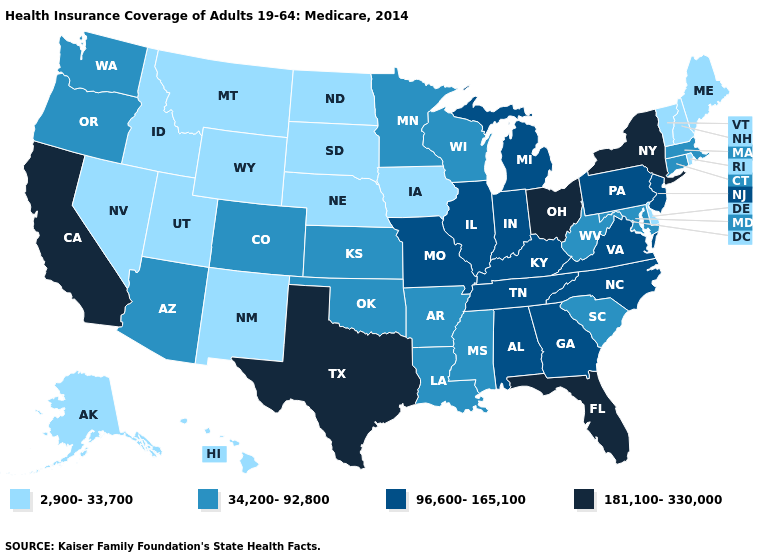Is the legend a continuous bar?
Quick response, please. No. Name the states that have a value in the range 2,900-33,700?
Be succinct. Alaska, Delaware, Hawaii, Idaho, Iowa, Maine, Montana, Nebraska, Nevada, New Hampshire, New Mexico, North Dakota, Rhode Island, South Dakota, Utah, Vermont, Wyoming. What is the value of Montana?
Write a very short answer. 2,900-33,700. What is the value of Wyoming?
Answer briefly. 2,900-33,700. What is the value of Delaware?
Write a very short answer. 2,900-33,700. Which states have the lowest value in the MidWest?
Answer briefly. Iowa, Nebraska, North Dakota, South Dakota. Which states have the lowest value in the USA?
Be succinct. Alaska, Delaware, Hawaii, Idaho, Iowa, Maine, Montana, Nebraska, Nevada, New Hampshire, New Mexico, North Dakota, Rhode Island, South Dakota, Utah, Vermont, Wyoming. Does Ohio have the highest value in the MidWest?
Concise answer only. Yes. Which states have the lowest value in the USA?
Be succinct. Alaska, Delaware, Hawaii, Idaho, Iowa, Maine, Montana, Nebraska, Nevada, New Hampshire, New Mexico, North Dakota, Rhode Island, South Dakota, Utah, Vermont, Wyoming. Name the states that have a value in the range 2,900-33,700?
Give a very brief answer. Alaska, Delaware, Hawaii, Idaho, Iowa, Maine, Montana, Nebraska, Nevada, New Hampshire, New Mexico, North Dakota, Rhode Island, South Dakota, Utah, Vermont, Wyoming. Name the states that have a value in the range 96,600-165,100?
Give a very brief answer. Alabama, Georgia, Illinois, Indiana, Kentucky, Michigan, Missouri, New Jersey, North Carolina, Pennsylvania, Tennessee, Virginia. Does New Mexico have the same value as Mississippi?
Answer briefly. No. Does Virginia have a higher value than Florida?
Keep it brief. No. What is the value of Montana?
Quick response, please. 2,900-33,700. Does Utah have a lower value than Michigan?
Short answer required. Yes. 